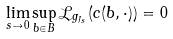<formula> <loc_0><loc_0><loc_500><loc_500>\lim _ { s \to 0 } \sup _ { b \in B } \mathcal { L } _ { g _ { J _ { s } } } ( c ( b , \cdot ) ) = 0</formula> 